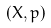<formula> <loc_0><loc_0><loc_500><loc_500>( X , p )</formula> 